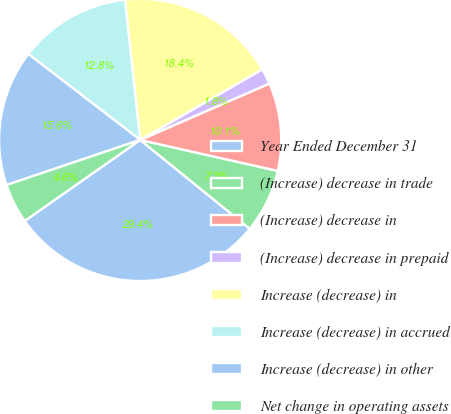Convert chart. <chart><loc_0><loc_0><loc_500><loc_500><pie_chart><fcel>Year Ended December 31<fcel>(Increase) decrease in trade<fcel>(Increase) decrease in<fcel>(Increase) decrease in prepaid<fcel>Increase (decrease) in<fcel>Increase (decrease) in accrued<fcel>Increase (decrease) in other<fcel>Net change in operating assets<nl><fcel>29.42%<fcel>7.32%<fcel>10.08%<fcel>1.8%<fcel>18.37%<fcel>12.85%<fcel>15.61%<fcel>4.56%<nl></chart> 